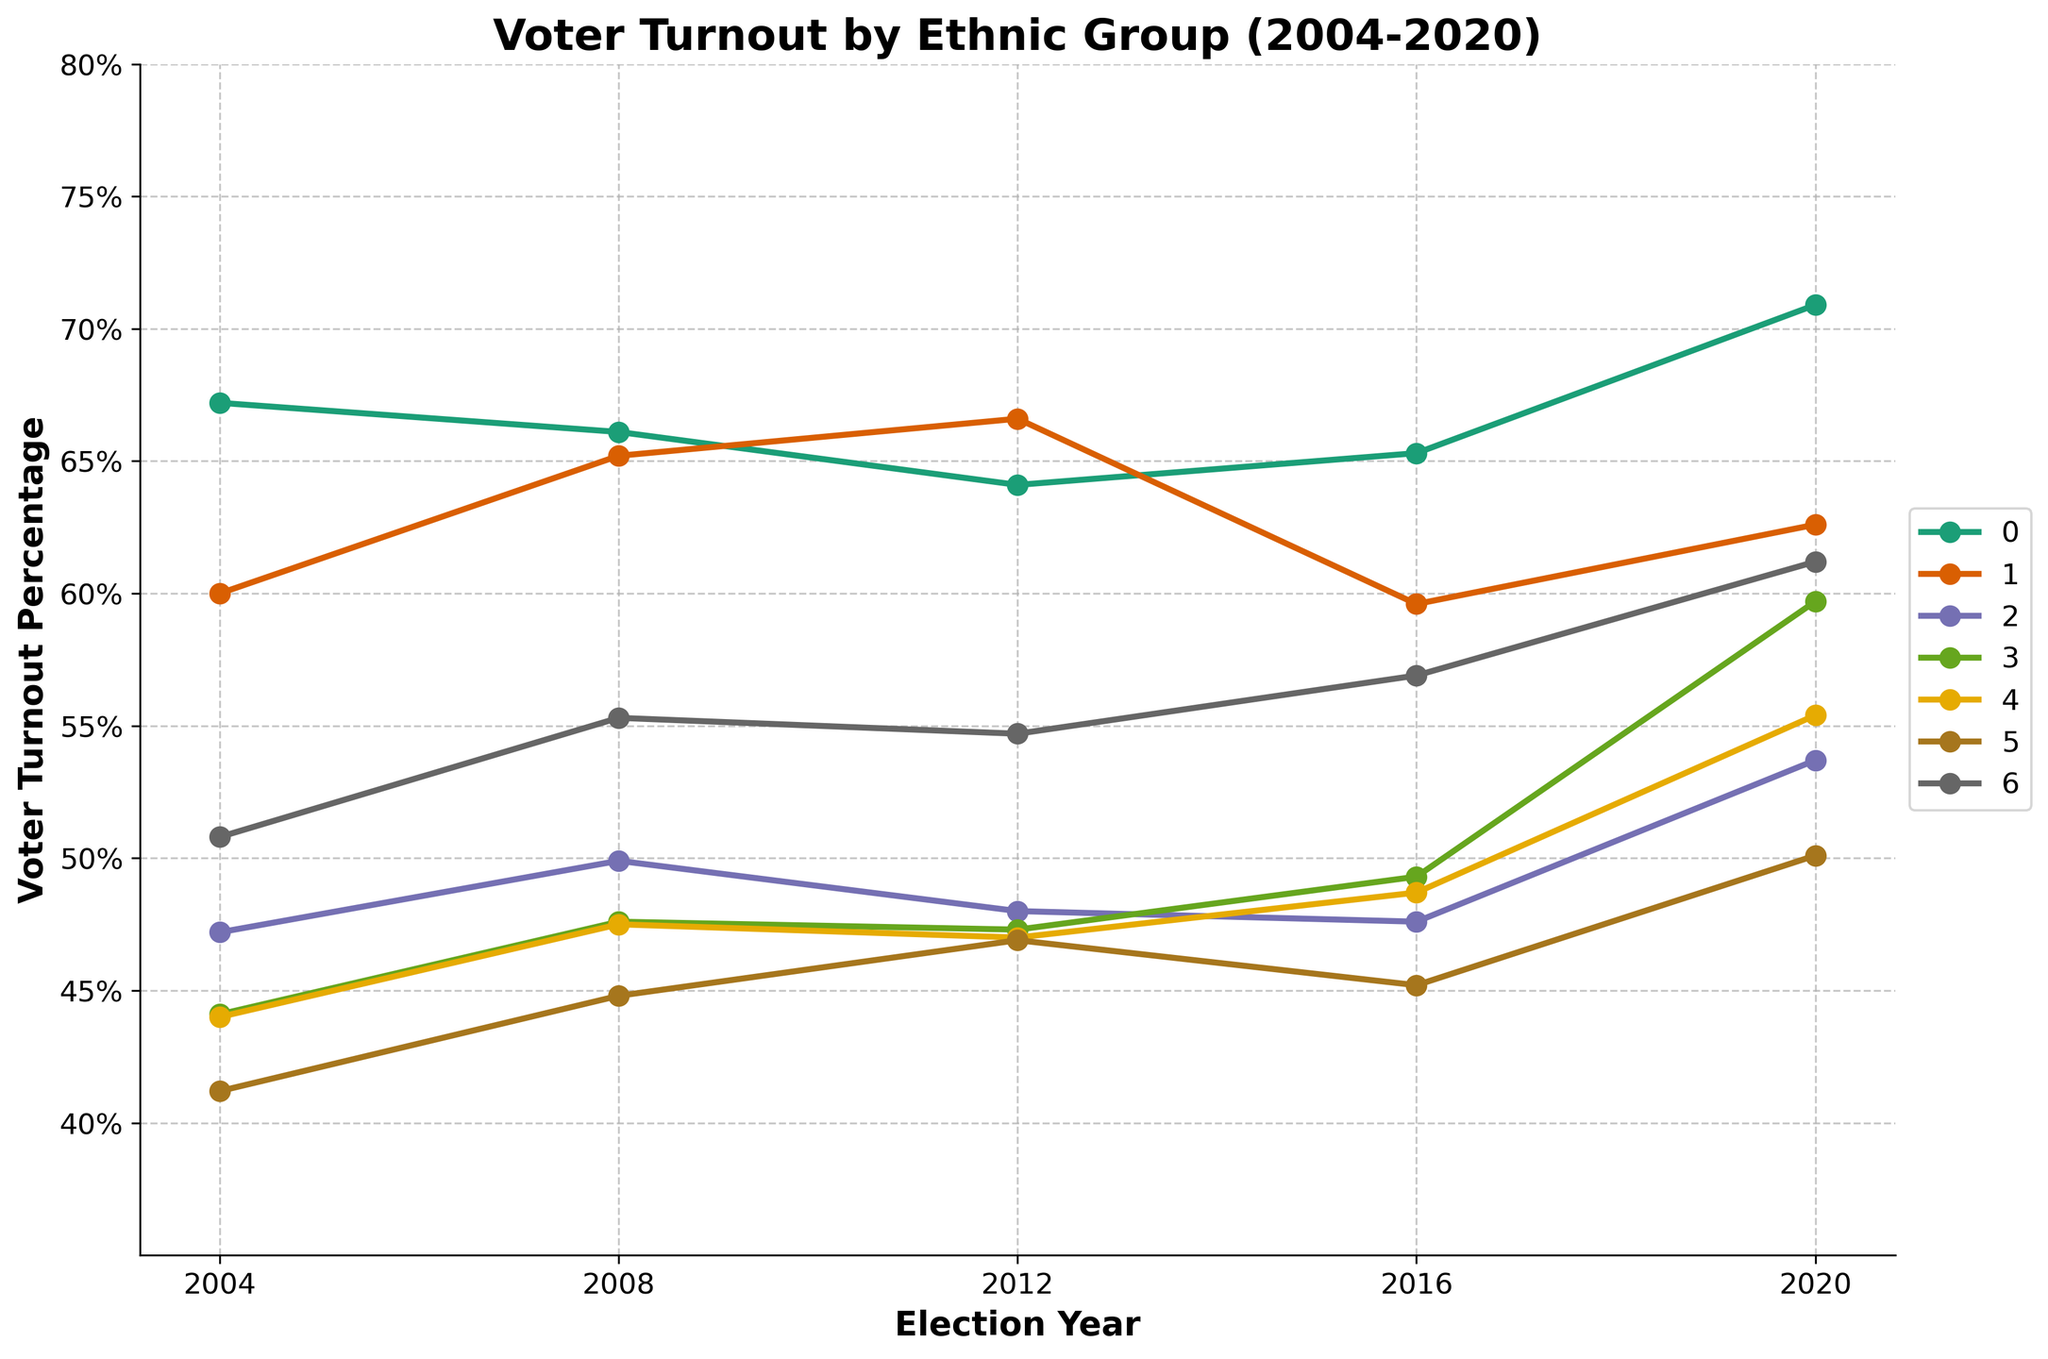What was the voter turnout percentage for the White non-Hispanic group in 2020? Locate the White non-Hispanic line on the plot and look at the value for the year 2020.
Answer: 70.9% Which ethnic group had the lowest voter turnout percentage in 2004? Identify the lowest point among all the lines for the year 2004. The lowest point is for the Pacific Islander group.
Answer: Pacific Islander Did the voter turnout percentage for the Black group increase or decrease between 2008 and 2016? Compare the Black group's turnout percentages for 2008 and 2016. It decreased from 65.2% to 59.6%.
Answer: Decrease Which two ethnic groups had nearly identical voter turnout percentages in 2012? Compare the voter turnout percentages for all groups in 2012. Black (66.6%) and White non-Hispanic (64.1%) are the closest, but not identical, hence it should be an exact check. Native American (47.0%) and Asian (47.3%) have nearly identical percentages around 47%.
Answer: Native American, Asian By how many percentage points did the voter turnout for the Hispanic group change from 2004 to 2020? Subtract the 2004 percentage from the 2020 percentage for the Hispanic group. 53.7% - 47.2% = 6.5 percentage points.
Answer: 6.5% Which ethnic group showed the largest increase in voter turnout percentage from 2016 to 2020? Compare the voter turnout increases for all groups from 2016 to 2020. The White non-Hispanic group increased by 5.6 percentage points (70.9% - 65.3%).
Answer: White non-Hispanic How does the voter turnout percentage for the Multiracial group in 2008 compare to the Pacific Islander group in the same year? Look at the values for both groups in 2008. Multiracial is 55.3%, Pacific Islander is 44.8%. Multiracial is higher.
Answer: Multiracial is higher What is the average voter turnout percentage for the Asian group across all five elections? Add the percentages: 44.1 + 47.6 + 47.3 + 49.3 + 59.7 = 248. Then divide by the number of elections (5): 248/5 = 49.6%.
Answer: 49.6% Which ethnic group had a voter turnout percentage above 60% in 2020? Identify all groups that have percentages above 60% in 2020. The groups are White non-Hispanic (70.9%), Black (62.6%), and Multiracial (61.2%).
Answer: White non-Hispanic, Black, Multiracial 